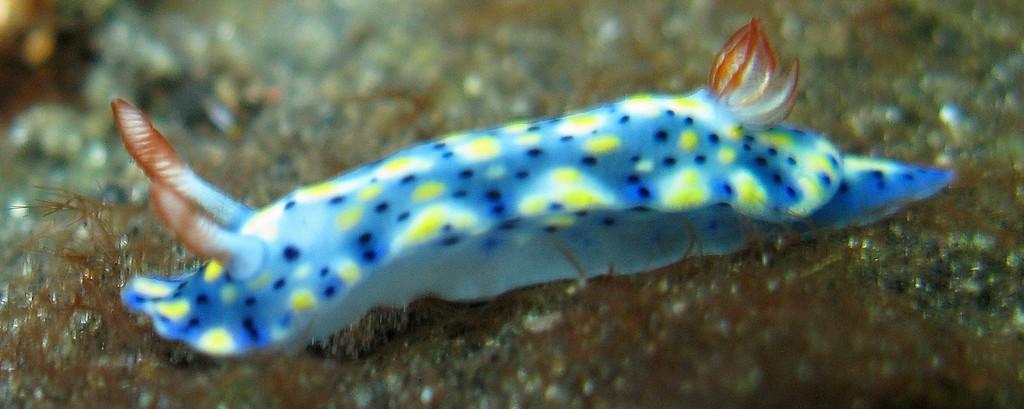What type of creature is in the image? There is an aquatic animal in the image. What colors can be seen on the aquatic animal? The aquatic animal has blue, white, yellow, and brown colors. Can you describe the background of the image? The background of the image is blurred. How many cherries are on the lip of the aquatic animal in the image? There are no cherries or lips present in the image; it features an aquatic animal with specific colors and a blurred background. 